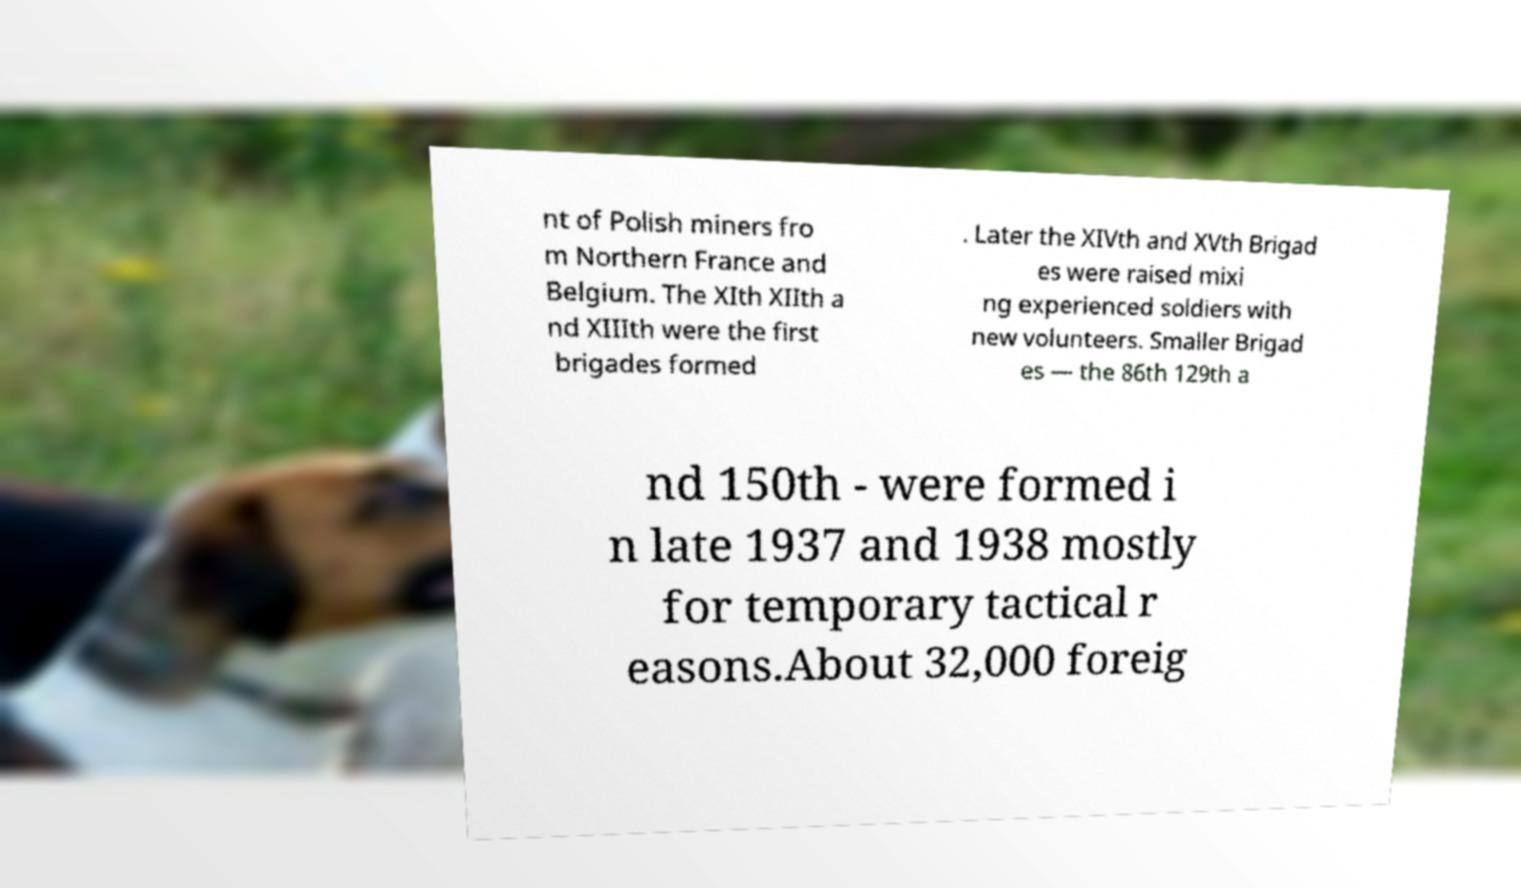For documentation purposes, I need the text within this image transcribed. Could you provide that? nt of Polish miners fro m Northern France and Belgium. The XIth XIIth a nd XIIIth were the first brigades formed . Later the XIVth and XVth Brigad es were raised mixi ng experienced soldiers with new volunteers. Smaller Brigad es — the 86th 129th a nd 150th - were formed i n late 1937 and 1938 mostly for temporary tactical r easons.About 32,000 foreig 